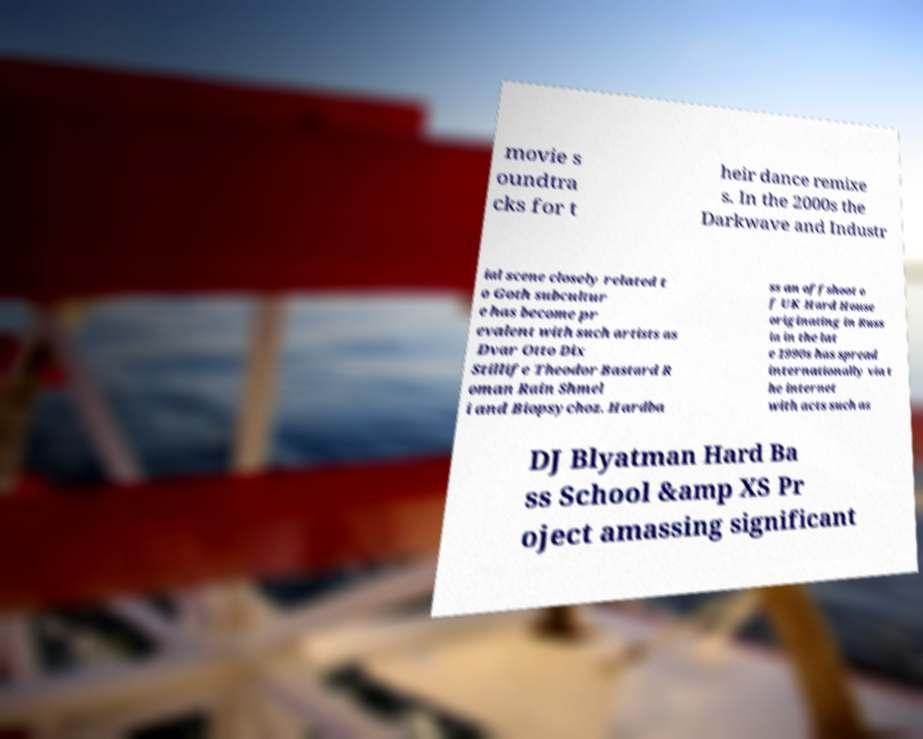There's text embedded in this image that I need extracted. Can you transcribe it verbatim? movie s oundtra cks for t heir dance remixe s. In the 2000s the Darkwave and Industr ial scene closely related t o Goth subcultur e has become pr evalent with such artists as Dvar Otto Dix Stillife Theodor Bastard R oman Rain Shmel i and Biopsychoz. Hardba ss an offshoot o f UK Hard House originating in Russ ia in the lat e 1990s has spread internationally via t he internet with acts such as DJ Blyatman Hard Ba ss School &amp XS Pr oject amassing significant 